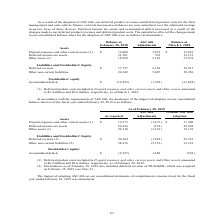According to Calamp's financial document, What were the results of the adoption of ASC 606 to the company? deferred product revenues and deferred product costs for the fleet management and auto vehicle finance verticals increased. The document states: "As a result of the adoption of ASC 606, our deferred product revenues and deferred product costs for the fleet management and auto vehicle finance ver..." Also, What was the balance of deferred income tax assets at February 28, 2018? According to the financial document, 31,581 (in thousands). The relevant text states: "12,000 1,891 $ 13,891 Deferred income tax assets 31,581 532 32,113 Other assets (1) 18,829 3,145 21,974 Liabilities and Stockholders' Equity Deferred reven..." Also, What was the balance of deferred income tax assets at March 1,2018? According to the financial document, 32,113 (in thousands). The relevant text states: "91 $ 13,891 Deferred income tax assets 31,581 532 32,113 Other assets (1) 18,829 3,145 21,974 Liabilities and Stockholders' Equity Deferred revenue $ 17,757..." Also, can you calculate: What were the balance of total assets at February 28, 2018? Based on the calculation: (12,000+31,581+18,829), the result is 62410 (in thousands). This is based on the information: "12,000 1,891 $ 13,891 Deferred income tax assets 31,581 532 32,113 Other assets (1) 18,829 3,145 21,974 Liabilities and Stockholders' Equity Deferred reven ome tax assets 31,581 532 32,113 Other asset..." The key data points involved are: 12,000, 18,829, 31,581. Also, can you calculate: What were the balance of total assets at March 1, 2018? Based on the calculation: (13,891+32,113+21,974), the result is 67978 (in thousands). This is based on the information: "ses and other current assets (1) $ 12,000 1,891 $ 13,891 Deferred income tax assets 31,581 532 32,113 Other assets (1) 18,829 3,145 21,974 Liabilities and S 91 $ 13,891 Deferred income tax assets 31,5..." The key data points involved are: 13,891, 21,974, 32,113. Also, can you calculate: What is the difference in balance of Deferred income tax assets and Deferred revenue at February 28, 2018? Based on the calculation: (31,581-17,757), the result is 13824 (in thousands). This is based on the information: "12,000 1,891 $ 13,891 Deferred income tax assets 31,581 532 32,113 Other assets (1) 18,829 3,145 21,974 Liabilities and Stockholders' Equity Deferred reven ities and Stockholders' Equity Deferred reve..." The key data points involved are: 17,757, 31,581. 